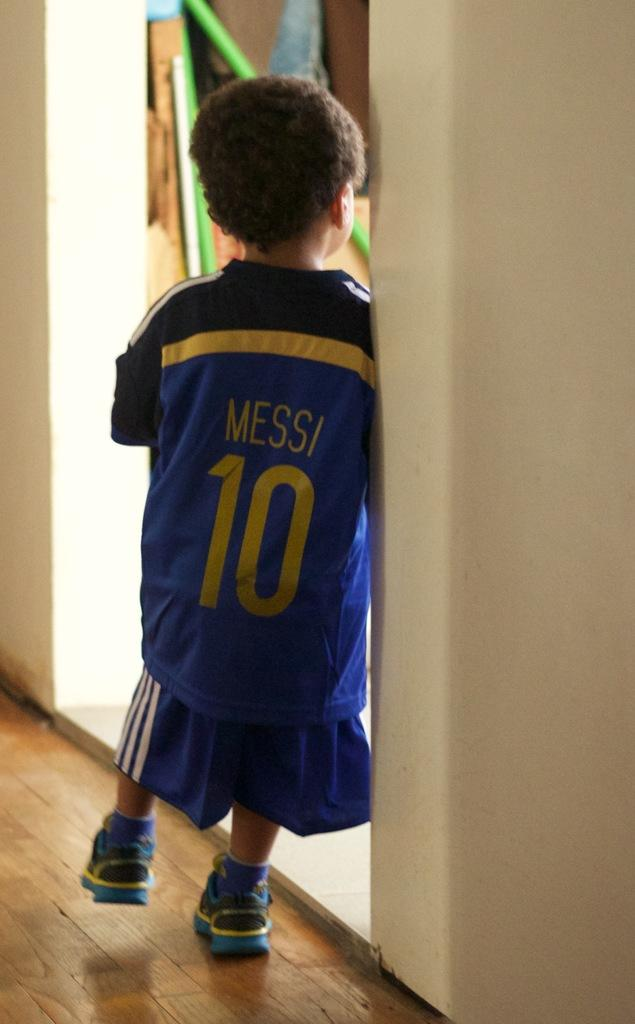<image>
Provide a brief description of the given image. A very young boy wears an athletic jersey labeled Messi 10. 